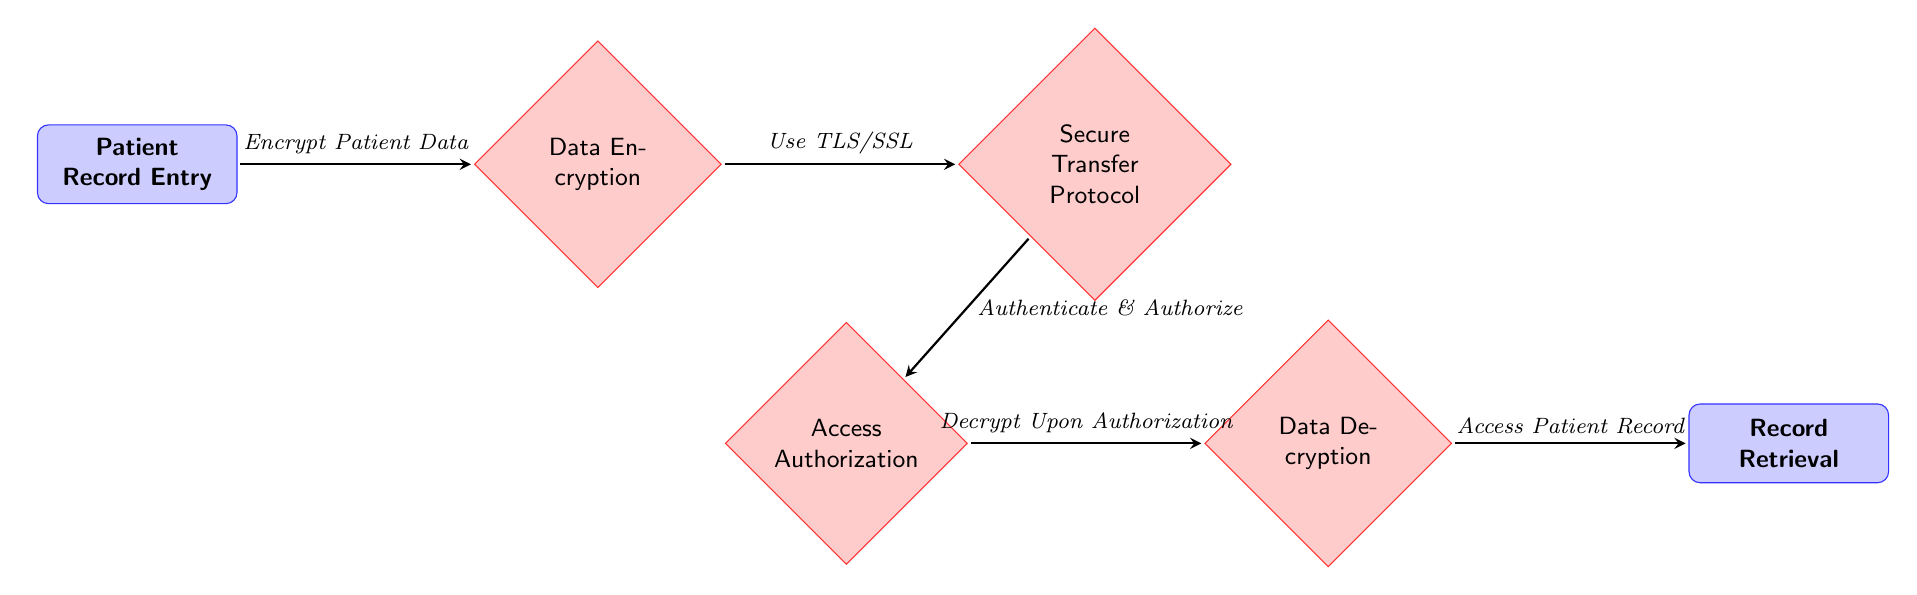What's the first node in the diagram? The first node is labeled "Patient Record Entry," indicating the beginning of the workflow for the encrypted transmission of patient health records.
Answer: Patient Record Entry How many processes are shown in the diagram? The diagram includes five processes: Data Encryption, Secure Transfer Protocol, Access Authorization, Data Decryption, and one implicit ending in Record Retrieval.
Answer: Five What technology is used for secure data transfer? The diagram specifies the use of "TLS/SSL" to ensure secure transmission of data during its transfer phase.
Answer: TLS/SSL What happens after Data Encryption? After Data Encryption, the next step is to follow the "Secure Transfer Protocol," which represents the transmission of the encrypted data securely to the authorized recipient.
Answer: Secure Transfer Protocol What is the purpose of the Access Authorization node? The Access Authorization node serves to "Authenticate & Authorize," which means verifying the identity of the requester and ensuring they have permission to access the data.
Answer: Authenticate & Authorize How does the patient record get accessed after decryption? The patient record is accessed after the decryption process, which occurs only if the accessing entity has been authorized, leading to the "Record Retrieval" phase.
Answer: Record Retrieval What follows after Decrypt Upon Authorization? Following the "Decrypt Upon Authorization," the workflow completes with "Access Patient Record," signifying the retrieval of the patient's health data.
Answer: Access Patient Record Which arrow indicates the step of encrypting patient data? The arrow coming from "Patient Record Entry" to "Data Encryption" indicates the step of encrypting patient data, labeled "Encrypt Patient Data."
Answer: Encrypt Patient Data What is the relationship between Data Encryption and Secure Transfer Protocol? The relationship is sequential; Data Encryption must occur first before the Secure Transfer Protocol is engaged to transmit the encrypted data.
Answer: Sequential relationship What will happen if access authorization fails? If access authorization fails, the workflow halts at the Access Authorization step and the data will not proceed to the decryption process, preventing access to the records.
Answer: Halt process 